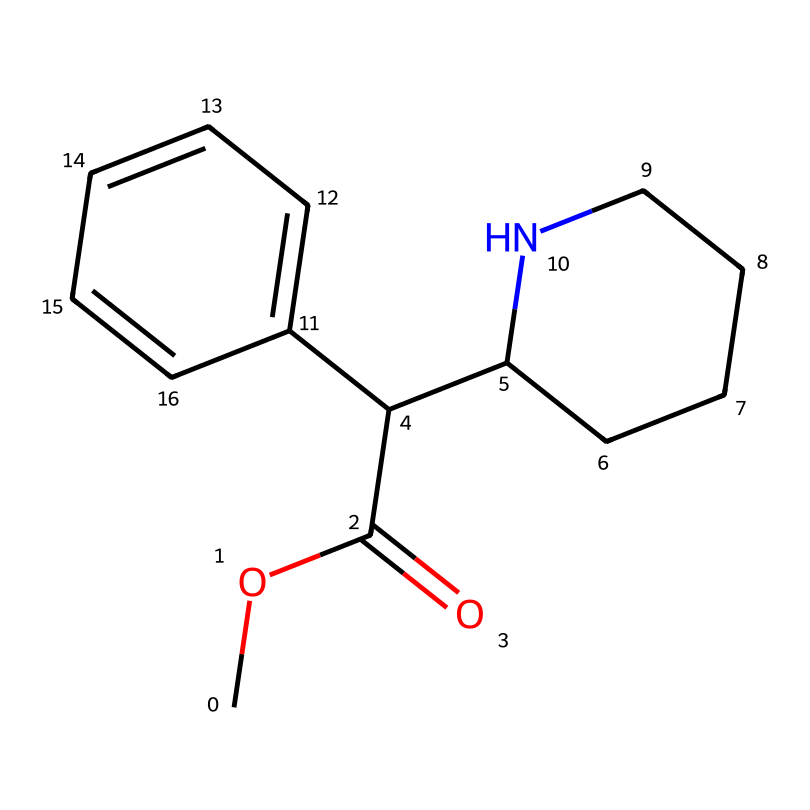What is the primary functional group present in methylphenidate? The structure shows a carbonyl group (C=O) attached to an oxygen atom (C(=O)O), indicating the presence of an ester functional group.
Answer: ester How many nitrogen atoms are present in the chemical structure of methylphenidate? By examining the SMILES representation, the structure contains one nitrogen atom indicated by "N" in "CCCCN".
Answer: 1 What type of medicinal activity does methylphenidate primarily exhibit? Methylphenidate acts as a central nervous system stimulant, which is primarily derived from its ability to increase dopamine levels.
Answer: stimulant What is the total number of carbon atoms in methylphenidate? Counting all the carbon atoms visible in the structure, there are 15 carbon atoms present in methylphenidate.
Answer: 15 Which substructure contributes to the drug's potential side effects related to the cardiovascular system? The presence of a phenyl ring (see "C1=CC=CC=C1") is associated with side effects, particularly in stimulating cardiovascular activity.
Answer: phenyl ring Does methylphenidate contain any aromatic rings? Yes, the chemical structure has a benzene-like structure (C1=CC=CC=C1), which is aromatic due to alternating double bonds.
Answer: yes What is the molecular formula of methylphenidate? By converting the information from the SMILES representation into a standard format, it is found that the molecular formula is C14H19NO2.
Answer: C14H19NO2 